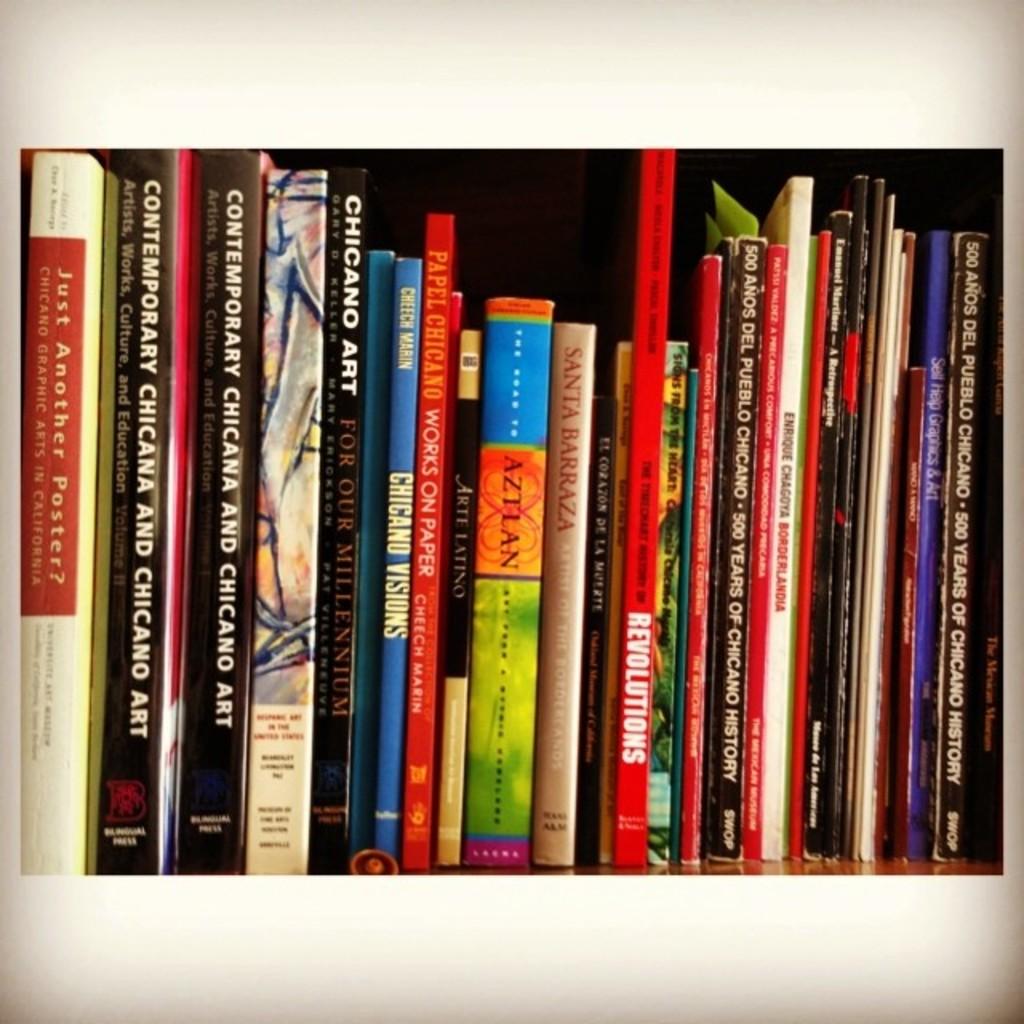What is the name of the first book on the left?
Ensure brevity in your answer.  Just another poster?. Who is the author of "chincano visions"?
Your answer should be very brief. Cheech marin. 